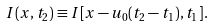Convert formula to latex. <formula><loc_0><loc_0><loc_500><loc_500>I ( x , t _ { 2 } ) \equiv I [ x - u _ { 0 } ( t _ { 2 } - t _ { 1 } ) , t _ { 1 } ] .</formula> 